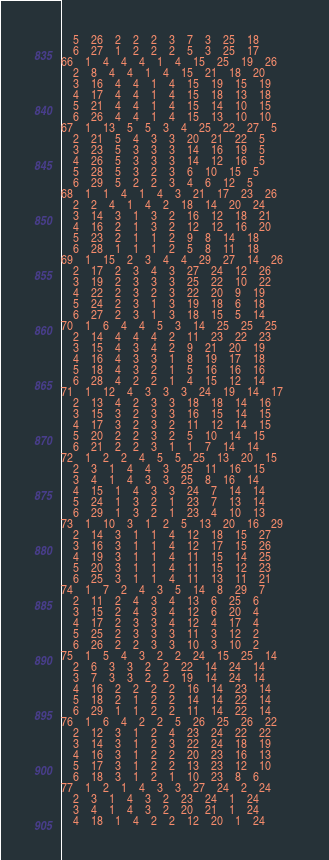Convert code to text. <code><loc_0><loc_0><loc_500><loc_500><_ObjectiveC_>	5	26	2	2	2	3	7	3	25	18	
	6	27	1	2	2	2	5	3	25	17	
66	1	4	4	4	1	4	15	25	19	26	
	2	8	4	4	1	4	15	21	18	20	
	3	16	4	4	1	4	15	19	15	19	
	4	17	4	4	1	4	15	18	13	18	
	5	21	4	4	1	4	15	14	10	15	
	6	26	4	4	1	4	15	13	10	10	
67	1	13	5	5	3	4	25	22	27	5	
	2	21	5	4	3	3	20	21	22	5	
	3	23	5	3	3	3	14	16	19	5	
	4	26	5	3	3	3	14	12	16	5	
	5	28	5	3	2	3	6	10	15	5	
	6	29	5	2	2	3	4	6	12	5	
68	1	1	4	1	4	3	21	17	23	26	
	2	2	4	1	4	2	18	14	20	24	
	3	14	3	1	3	2	16	12	18	21	
	4	16	2	1	3	2	12	12	16	20	
	5	23	2	1	1	2	9	8	14	18	
	6	28	1	1	1	2	5	8	11	18	
69	1	15	2	3	4	4	29	27	14	26	
	2	17	2	3	4	3	27	24	12	26	
	3	19	2	3	3	3	25	22	10	22	
	4	22	2	3	2	3	22	20	9	19	
	5	24	2	3	1	3	19	18	6	18	
	6	27	2	3	1	3	18	15	5	14	
70	1	6	4	4	5	3	14	25	25	25	
	2	14	4	4	4	2	11	23	22	23	
	3	15	4	3	4	2	9	21	20	19	
	4	16	4	3	3	1	8	19	17	18	
	5	18	4	3	2	1	5	16	16	16	
	6	28	4	2	2	1	4	15	12	14	
71	1	12	4	3	3	3	24	19	14	17	
	2	13	4	2	3	3	18	18	14	16	
	3	15	3	2	3	3	16	15	14	15	
	4	17	3	2	3	2	11	12	14	15	
	5	20	2	2	3	2	5	10	14	15	
	6	21	2	2	3	1	1	7	14	14	
72	1	2	2	4	5	5	25	13	20	15	
	2	3	1	4	4	3	25	11	16	15	
	3	4	1	4	3	3	25	8	16	14	
	4	15	1	4	3	3	24	7	14	14	
	5	24	1	3	2	1	23	7	13	14	
	6	29	1	3	2	1	23	4	10	13	
73	1	10	3	1	2	5	13	20	16	29	
	2	14	3	1	1	4	12	18	15	27	
	3	16	3	1	1	4	12	17	15	26	
	4	19	3	1	1	4	11	15	14	25	
	5	20	3	1	1	4	11	15	12	23	
	6	25	3	1	1	4	11	13	11	21	
74	1	7	2	4	3	5	14	8	29	7	
	2	11	2	4	3	4	13	6	25	6	
	3	15	2	4	3	4	12	6	20	4	
	4	17	2	3	3	4	12	4	17	4	
	5	25	2	3	3	3	11	3	12	2	
	6	26	2	2	3	3	10	3	10	2	
75	1	5	4	3	2	2	24	15	25	14	
	2	6	3	3	2	2	22	14	24	14	
	3	7	3	3	2	2	19	14	24	14	
	4	16	2	2	2	2	16	14	23	14	
	5	18	2	1	2	2	14	14	22	14	
	6	29	1	1	2	2	11	14	22	14	
76	1	6	4	2	2	5	26	25	26	22	
	2	12	3	1	2	4	23	24	22	22	
	3	14	3	1	2	3	22	24	18	19	
	4	16	3	1	2	2	20	23	16	13	
	5	17	3	1	2	2	13	23	12	10	
	6	18	3	1	2	1	10	23	8	6	
77	1	2	1	4	3	3	27	24	2	24	
	2	3	1	4	3	2	23	24	1	24	
	3	4	1	4	3	2	20	21	1	24	
	4	18	1	4	2	2	12	20	1	24	</code> 